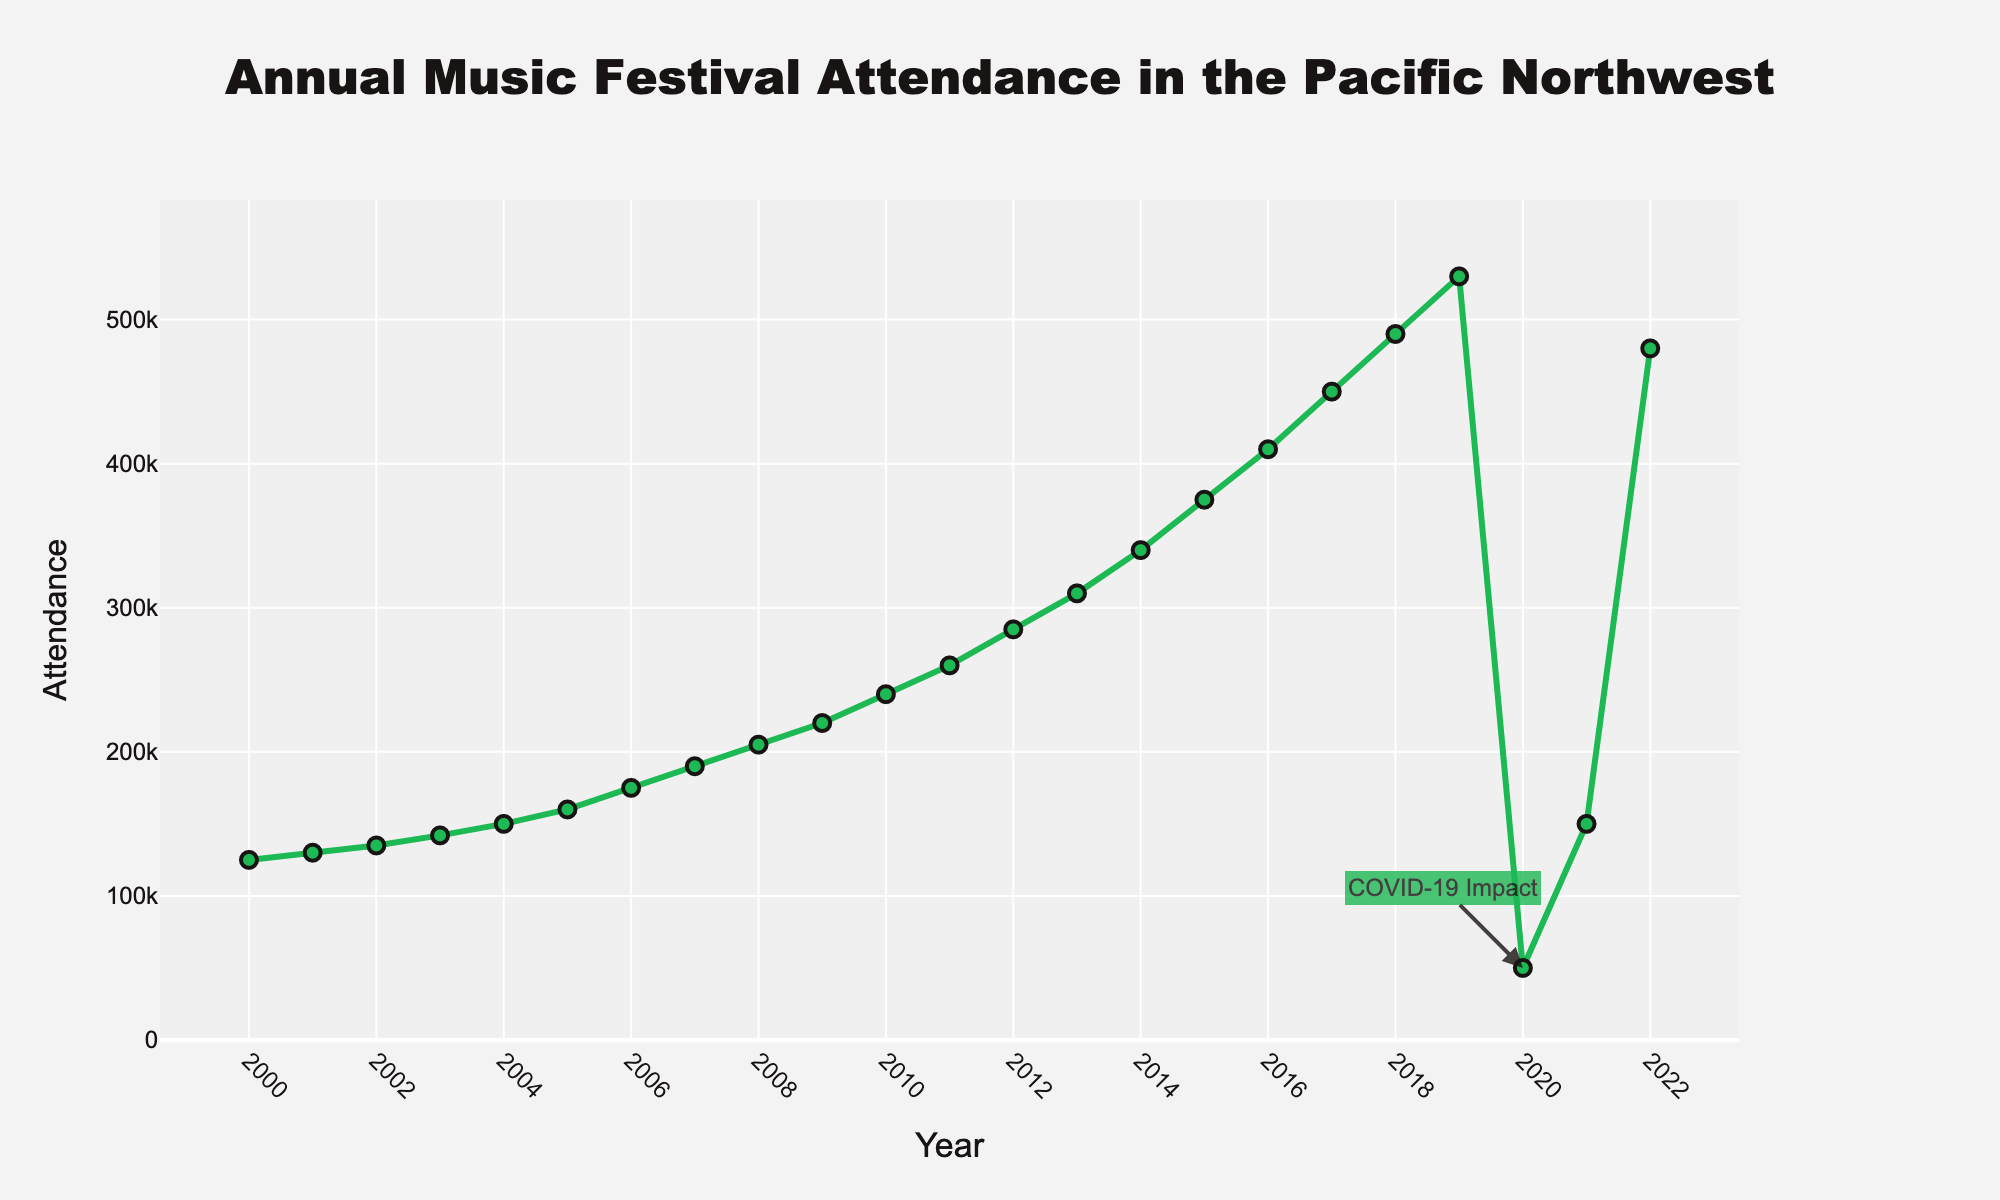What year had the highest festival attendance before 2020? To find the highest festival attendance before 2020, we look at the years from 2000 to 2019. Among these, 2019 has the highest attendance at 530,000.
Answer: 2019 How did festival attendance change from 2019 to 2020? The attendance decreased from 530,000 in 2019 to 50,000 in 2020. The decrease is 530,000 - 50,000 = 480,000.
Answer: Decreased by 480,000 What is the average festival attendance from 2000 to 2019? First, sum the attendance values from 2000 to 2019, which gives 4,557,000. Then, divide by the number of years, which is 20. The average is 4,557,000 / 20 = 227,850.
Answer: 227,850 What was the festival attendance in 2021 compared to 2022? The attendance was 150,000 in 2021 and 480,000 in 2022. Comparing these, 2022 has higher attendance.
Answer: 2022 had higher attendance What is the median festival attendance value from 2010 to 2019? First, list the attendance values from 2010 to 2019: 240,000, 260,000, 285,000, 310,000, 340,000, 375,000, 410,000, 450,000, 490,000, 530,000. Ordering them, the median is the middle value, which is 340,000.
Answer: 340,000 Which year had the most significant drop in festival attendance and by how much? The most significant drop is from 2019 (530,000) to 2020 (50,000). The drop is 530,000 - 50,000 = 480,000.
Answer: 2019 to 2020, 480,000 What visual highlights the impact of COVID-19 on festival attendance in the graph? There is an annotation with the text "COVID-19 Impact" pointing at the data point for the year 2020, which visually indicates the impact of COVID-19.
Answer: Annotation with "COVID-19 Impact" How does the color and style of the line trace emphasize the data? The line trace is green and has a thick (width 3) line to highlight the trend. Markers are used at each data point to distinguish yearly values clearly.
Answer: Green color, thick line, markers 